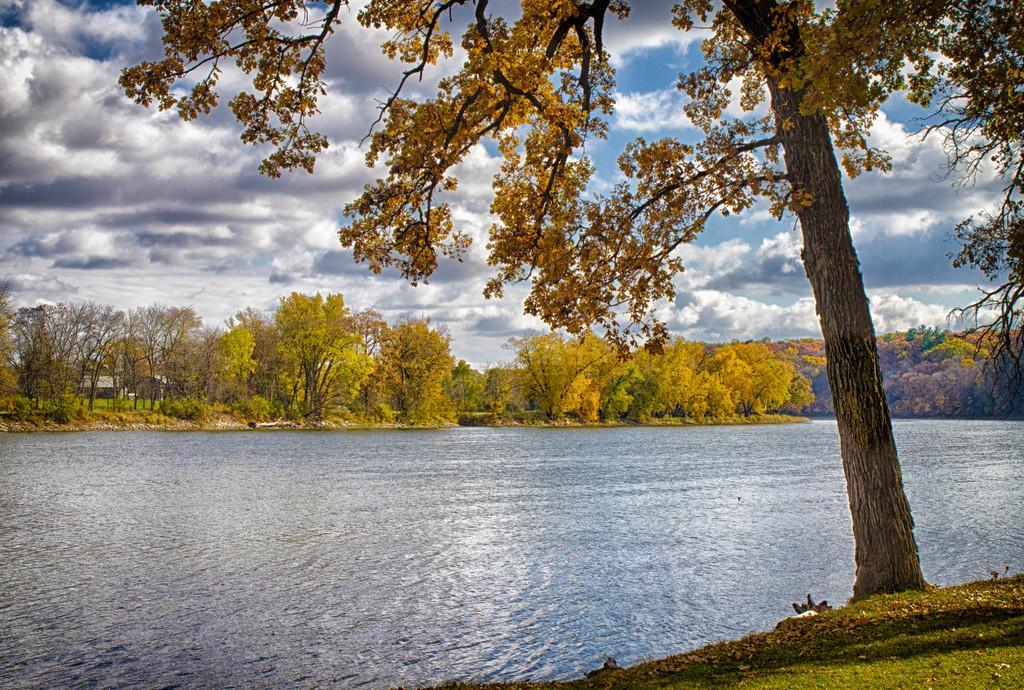Could you give a brief overview of what you see in this image? In this image we can see trees, plants, water and we can also see some clouds in the sky. 